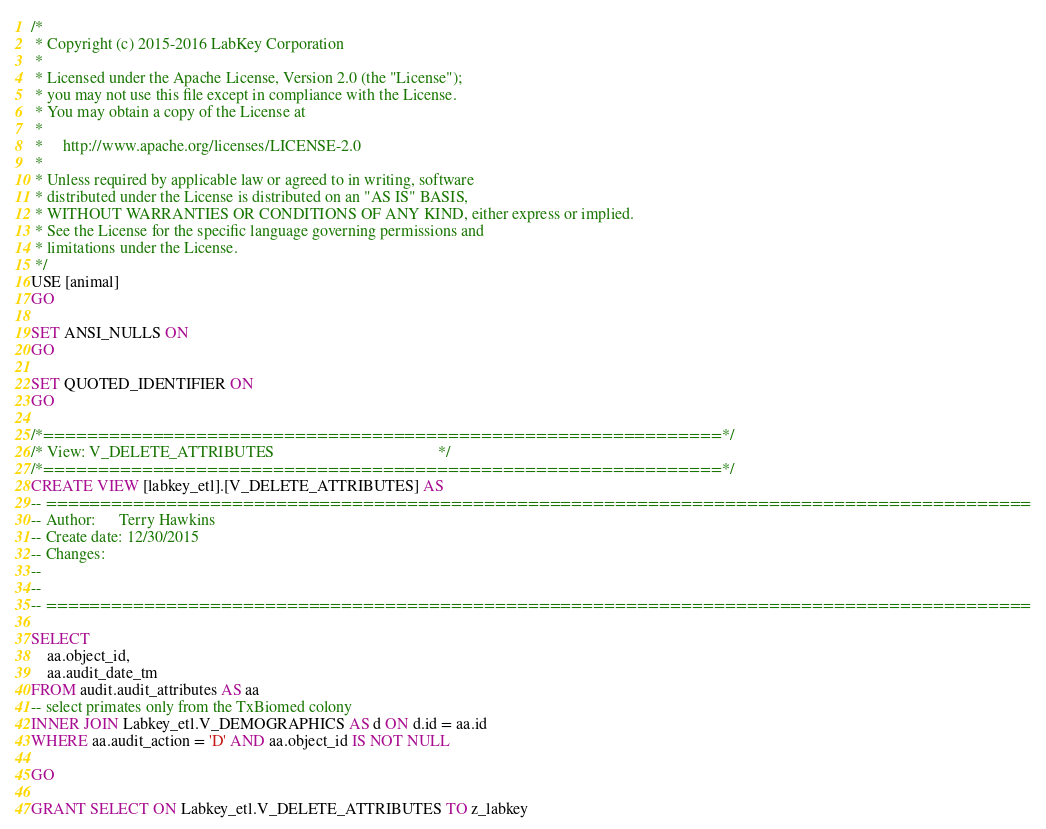<code> <loc_0><loc_0><loc_500><loc_500><_SQL_>/*
 * Copyright (c) 2015-2016 LabKey Corporation
 *
 * Licensed under the Apache License, Version 2.0 (the "License");
 * you may not use this file except in compliance with the License.
 * You may obtain a copy of the License at
 *
 *     http://www.apache.org/licenses/LICENSE-2.0
 *
 * Unless required by applicable law or agreed to in writing, software
 * distributed under the License is distributed on an "AS IS" BASIS,
 * WITHOUT WARRANTIES OR CONDITIONS OF ANY KIND, either express or implied.
 * See the License for the specific language governing permissions and
 * limitations under the License.
 */
USE [animal]
GO

SET ANSI_NULLS ON
GO

SET QUOTED_IDENTIFIER ON
GO

/*==============================================================*/
/* View: V_DELETE_ATTRIBUTES                                         */
/*==============================================================*/
CREATE VIEW [labkey_etl].[V_DELETE_ATTRIBUTES] AS
-- ==========================================================================================
-- Author:		Terry Hawkins
-- Create date: 12/30/2015
-- Changes:
--
--
-- ==========================================================================================

SELECT 
	aa.object_id,
	aa.audit_date_tm
FROM audit.audit_attributes AS aa
-- select primates only from the TxBiomed colony
INNER JOIN Labkey_etl.V_DEMOGRAPHICS AS d ON d.id = aa.id
WHERE aa.audit_action = 'D' AND aa.object_id IS NOT NULL

GO

GRANT SELECT ON Labkey_etl.V_DELETE_ATTRIBUTES TO z_labkey </code> 